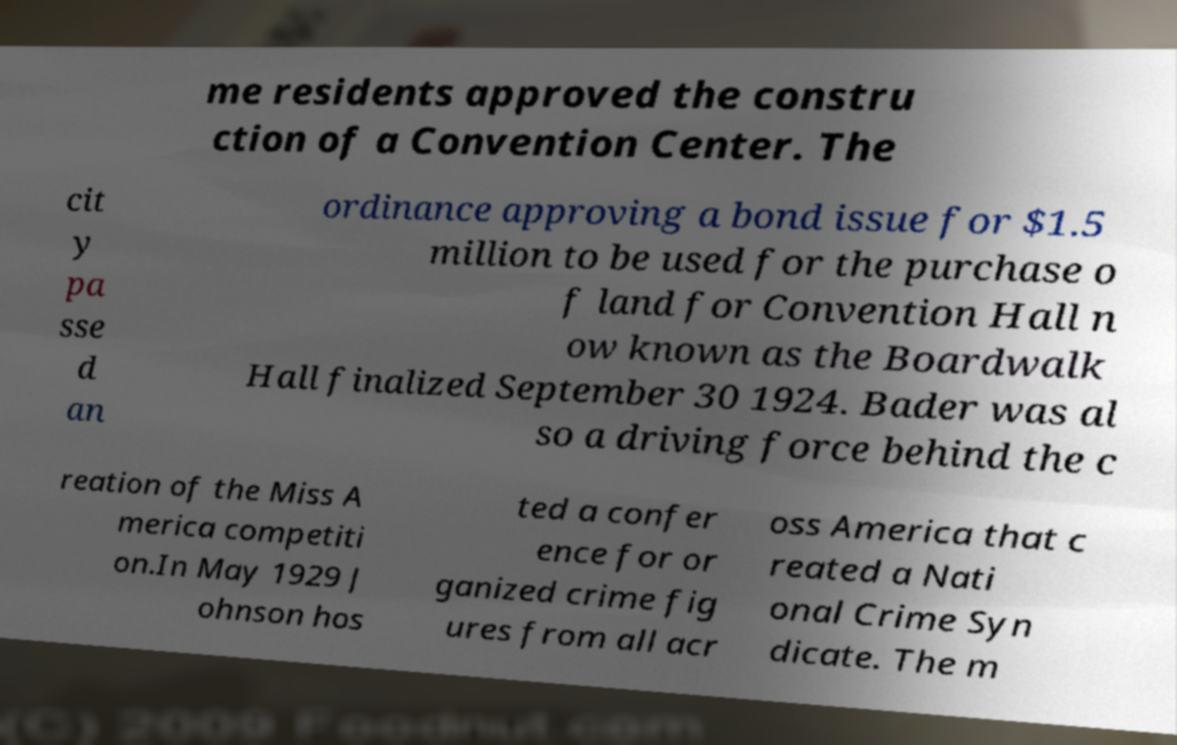I need the written content from this picture converted into text. Can you do that? me residents approved the constru ction of a Convention Center. The cit y pa sse d an ordinance approving a bond issue for $1.5 million to be used for the purchase o f land for Convention Hall n ow known as the Boardwalk Hall finalized September 30 1924. Bader was al so a driving force behind the c reation of the Miss A merica competiti on.In May 1929 J ohnson hos ted a confer ence for or ganized crime fig ures from all acr oss America that c reated a Nati onal Crime Syn dicate. The m 